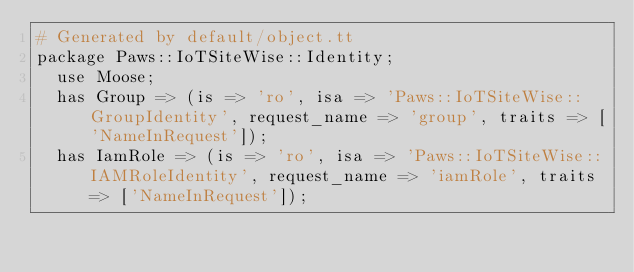Convert code to text. <code><loc_0><loc_0><loc_500><loc_500><_Perl_># Generated by default/object.tt
package Paws::IoTSiteWise::Identity;
  use Moose;
  has Group => (is => 'ro', isa => 'Paws::IoTSiteWise::GroupIdentity', request_name => 'group', traits => ['NameInRequest']);
  has IamRole => (is => 'ro', isa => 'Paws::IoTSiteWise::IAMRoleIdentity', request_name => 'iamRole', traits => ['NameInRequest']);</code> 